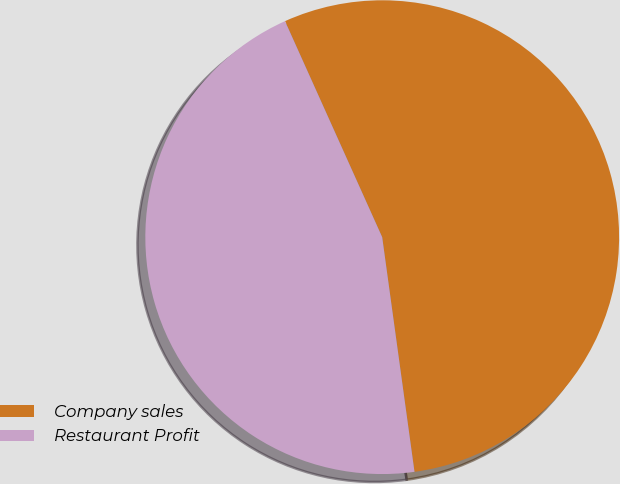Convert chart. <chart><loc_0><loc_0><loc_500><loc_500><pie_chart><fcel>Company sales<fcel>Restaurant Profit<nl><fcel>54.55%<fcel>45.45%<nl></chart> 